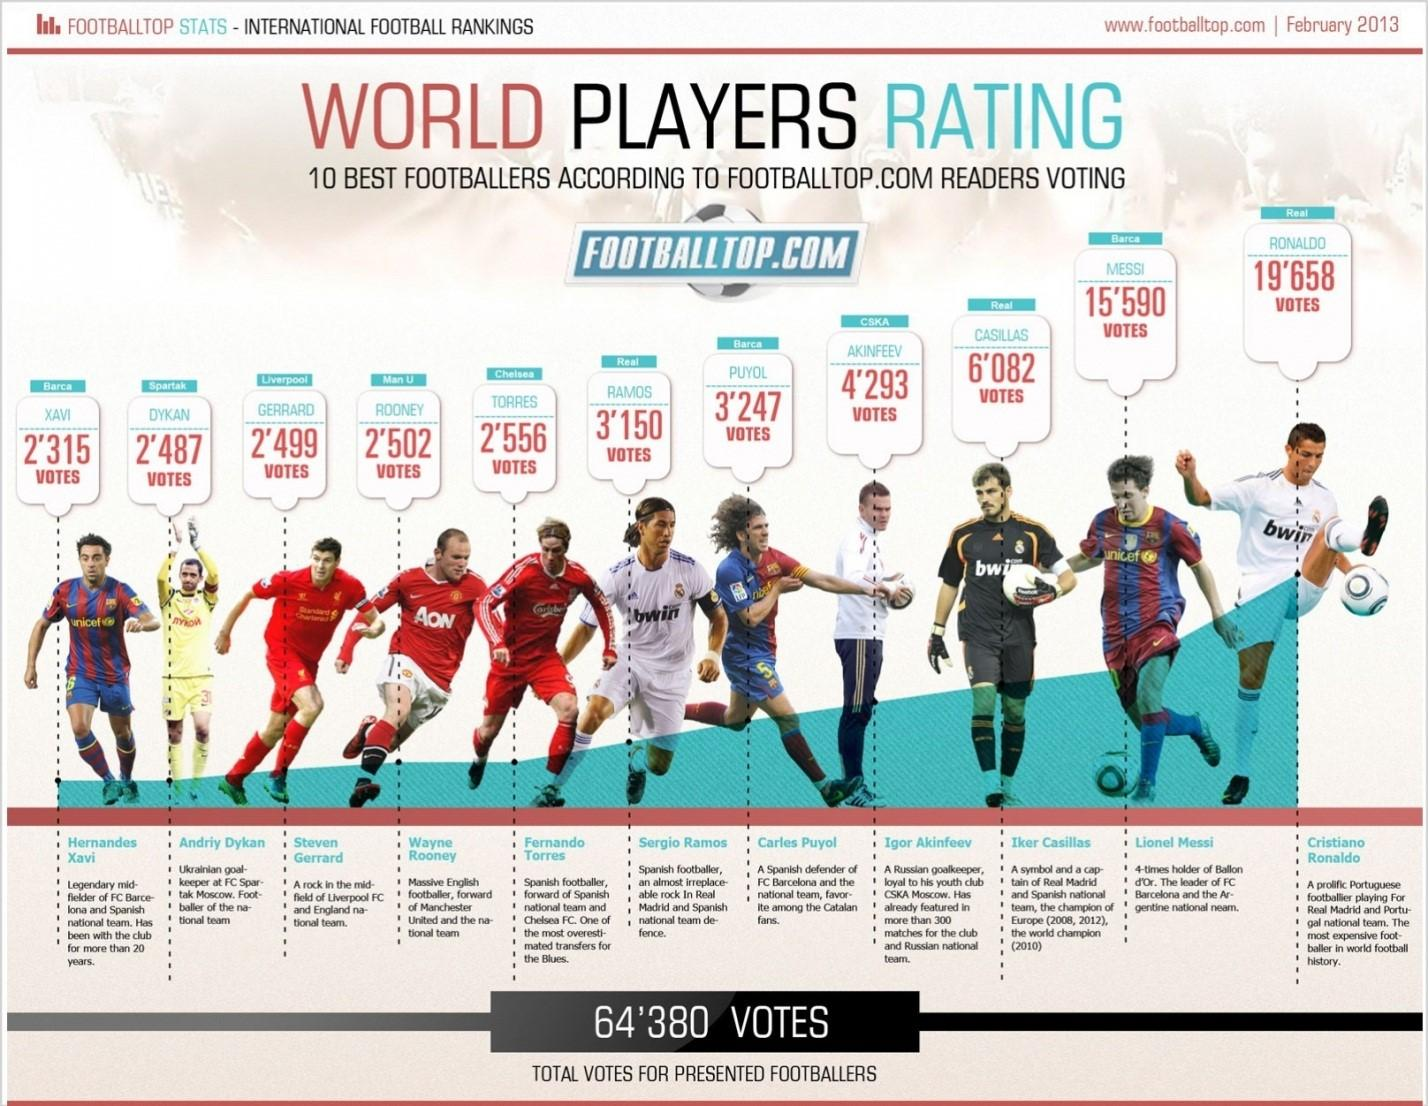Point out several critical features in this image. Casillas is the player rated immediately below Messi, who is widely considered to be one of the greatest footballers of all time. Cristiano Ronaldo's dress is white in color. There are 3 footballers wearing red shirts. The t-shirt of Xavi displays the name of the United Nations organization UNICEF. The difference in votes between the top two candidates is 4068. 